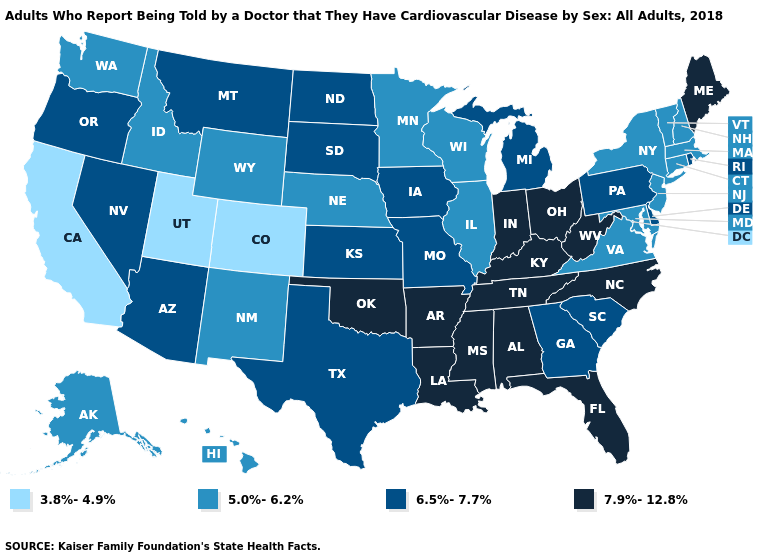Does Illinois have the lowest value in the MidWest?
Be succinct. Yes. What is the value of Massachusetts?
Short answer required. 5.0%-6.2%. What is the value of Idaho?
Short answer required. 5.0%-6.2%. Does Connecticut have a lower value than Kansas?
Write a very short answer. Yes. Is the legend a continuous bar?
Write a very short answer. No. What is the value of Louisiana?
Write a very short answer. 7.9%-12.8%. Does Alabama have the highest value in the South?
Give a very brief answer. Yes. Which states have the lowest value in the USA?
Answer briefly. California, Colorado, Utah. Is the legend a continuous bar?
Write a very short answer. No. Which states have the lowest value in the Northeast?
Short answer required. Connecticut, Massachusetts, New Hampshire, New Jersey, New York, Vermont. Which states have the lowest value in the South?
Short answer required. Maryland, Virginia. What is the highest value in the Northeast ?
Write a very short answer. 7.9%-12.8%. Does Nebraska have the lowest value in the MidWest?
Quick response, please. Yes. Does Arkansas have the highest value in the USA?
Keep it brief. Yes. Does the map have missing data?
Be succinct. No. 